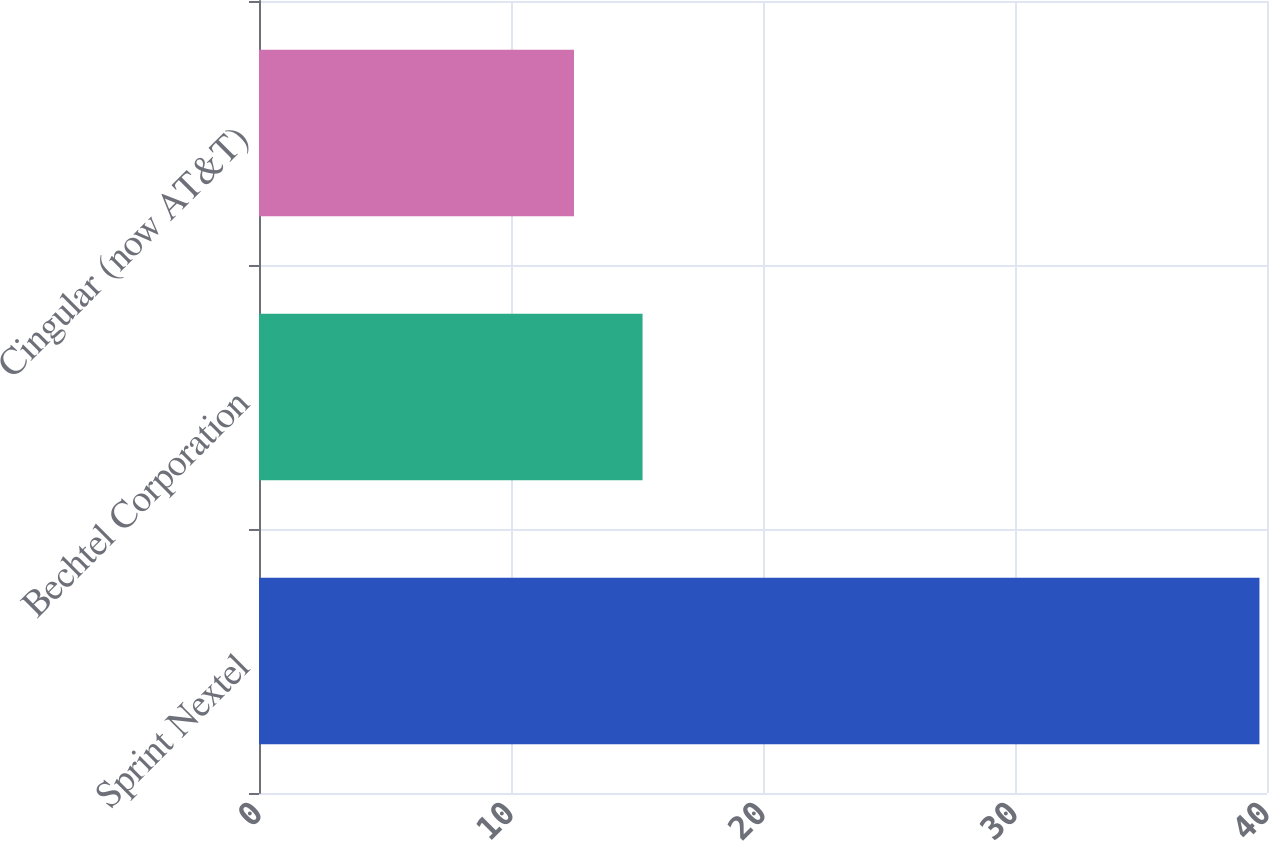Convert chart. <chart><loc_0><loc_0><loc_500><loc_500><bar_chart><fcel>Sprint Nextel<fcel>Bechtel Corporation<fcel>Cingular (now AT&T)<nl><fcel>39.7<fcel>15.22<fcel>12.5<nl></chart> 